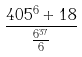<formula> <loc_0><loc_0><loc_500><loc_500>\frac { 4 0 5 ^ { 6 } + 1 8 } { \frac { 6 ^ { 3 7 } } { 6 } }</formula> 